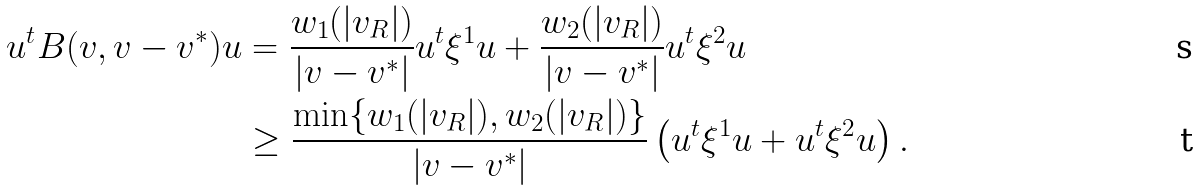Convert formula to latex. <formula><loc_0><loc_0><loc_500><loc_500>u ^ { t } { B } ( v , v - v ^ { * } ) u & = \frac { w _ { 1 } ( | v _ { R } | ) } { | v - v ^ { * } | } u ^ { t } \xi ^ { 1 } u + \frac { w _ { 2 } ( | v _ { R } | ) } { | v - v ^ { * } | } u ^ { t } \xi ^ { 2 } u \\ & \geq \frac { \min \{ w _ { 1 } ( | v _ { R } | ) , w _ { 2 } ( | v _ { R } | ) \} } { | v - v ^ { * } | } \left ( u ^ { t } \xi ^ { 1 } u + u ^ { t } \xi ^ { 2 } u \right ) .</formula> 